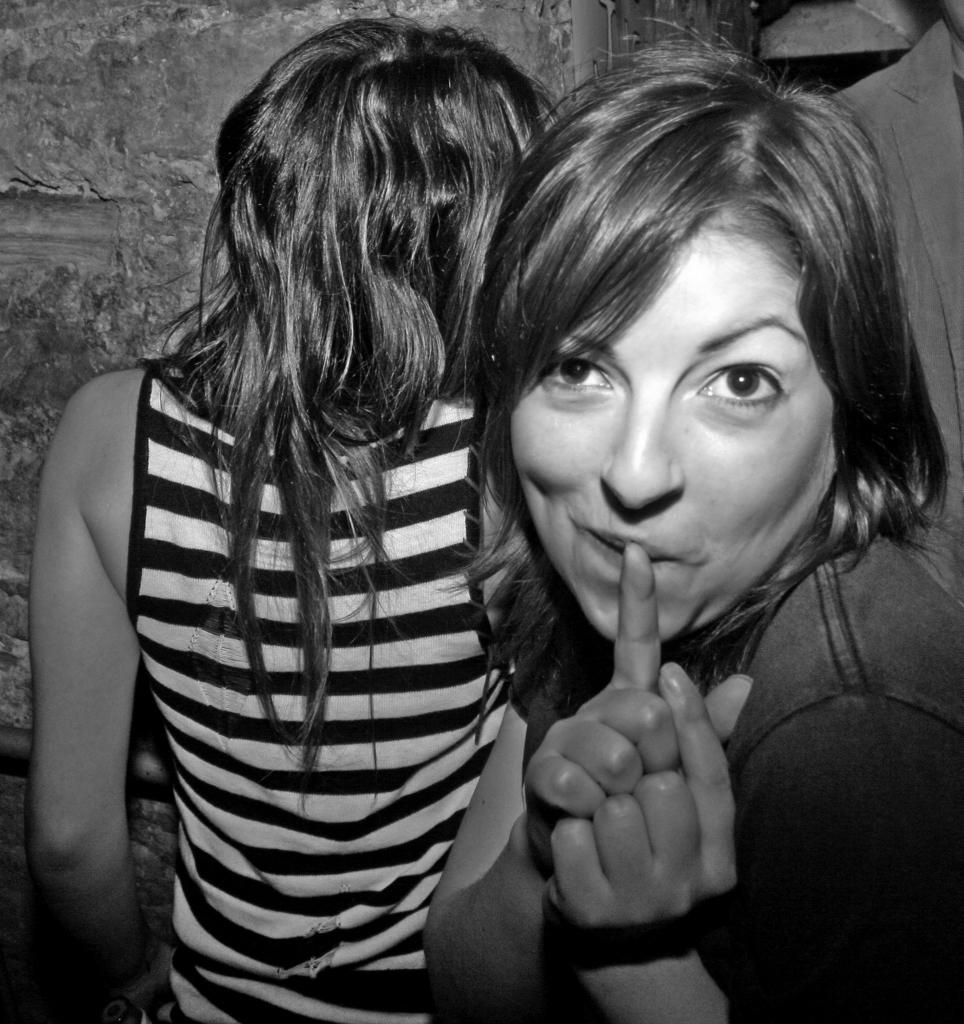How many people are in the image? There are two women in the image. Where are the women located in the image? The women are standing in the middle of the image. What can be seen in the background of the image? There is a wall in the background of the image. What type of act is the father performing in the image? There is no father or act present in the image; it features two women standing in the middle. What is the weight of the scale used for in the image? There is no weight scale present in the image. 